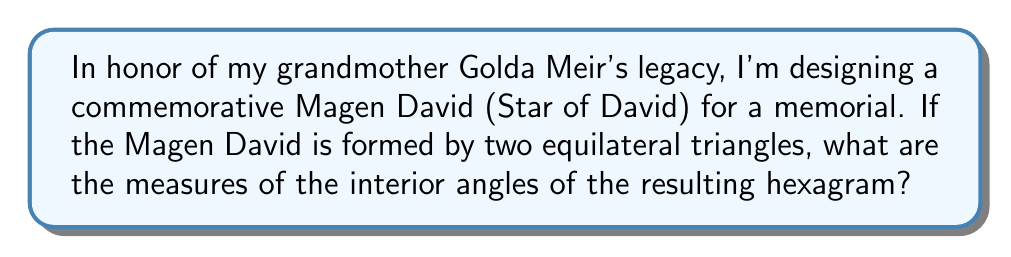Give your solution to this math problem. Let's approach this step-by-step:

1) A Magen David (Star of David) is composed of two overlapping equilateral triangles, forming a hexagram.

2) In an equilateral triangle, all angles are equal and measure 60°. This is because the sum of angles in any triangle is 180°, and 180° ÷ 3 = 60°.

3) When we overlay two equilateral triangles to form a Magen David, we create a hexagram with 12 interior angles.

4) These 12 angles can be divided into two groups:
   a) 6 angles at the points of the star
   b) 6 angles in the inner hexagon

5) For the angles at the points of the star:
   - Each of these is formed by two sides of the equilateral triangles meeting.
   - The measure of each of these angles is: 180° - 60° = 120°
   - This is because the angles on a straight line sum to 180°, and one 60° angle is taken by the equilateral triangle.

6) For the angles in the inner hexagon:
   - Each of these is formed by the intersection of sides from both triangles.
   - The measure of each of these angles is: 360° ÷ 6 = 60°
   - This is because the sum of angles in a hexagon is (6-2) × 180° = 720°, and 720° ÷ 12 = 60°

Therefore, the Magen David contains two types of interior angles: 120° at each point of the star, and 60° in the inner hexagon.

[asy]
unitsize(2cm);
pair A = (0,1), B = (sqrt(3)/2,-1/2), C = (-sqrt(3)/2,-1/2);
pair D = (0,-1), E = (-sqrt(3)/2,1/2), F = (sqrt(3)/2,1/2);

draw(A--B--C--cycle, blue);
draw(D--E--F--cycle, red);

dot(A); dot(B); dot(C); dot(D); dot(E); dot(F);

label("120°", A, N);
label("120°", B, SE);
label("120°", C, SW);
label("120°", D, S);
label("120°", E, NW);
label("120°", F, NE);

label("60°", (0,0), N);
label("60°", (sqrt(3)/4,1/4), E);
label("60°", (sqrt(3)/4,-1/4), SE);
label("60°", (-sqrt(3)/4,-1/4), SW);
label("60°", (-sqrt(3)/4,1/4), W);
label("60°", (0,1/2), N);
[/asy]
Answer: 120° at star points, 60° in inner hexagon 